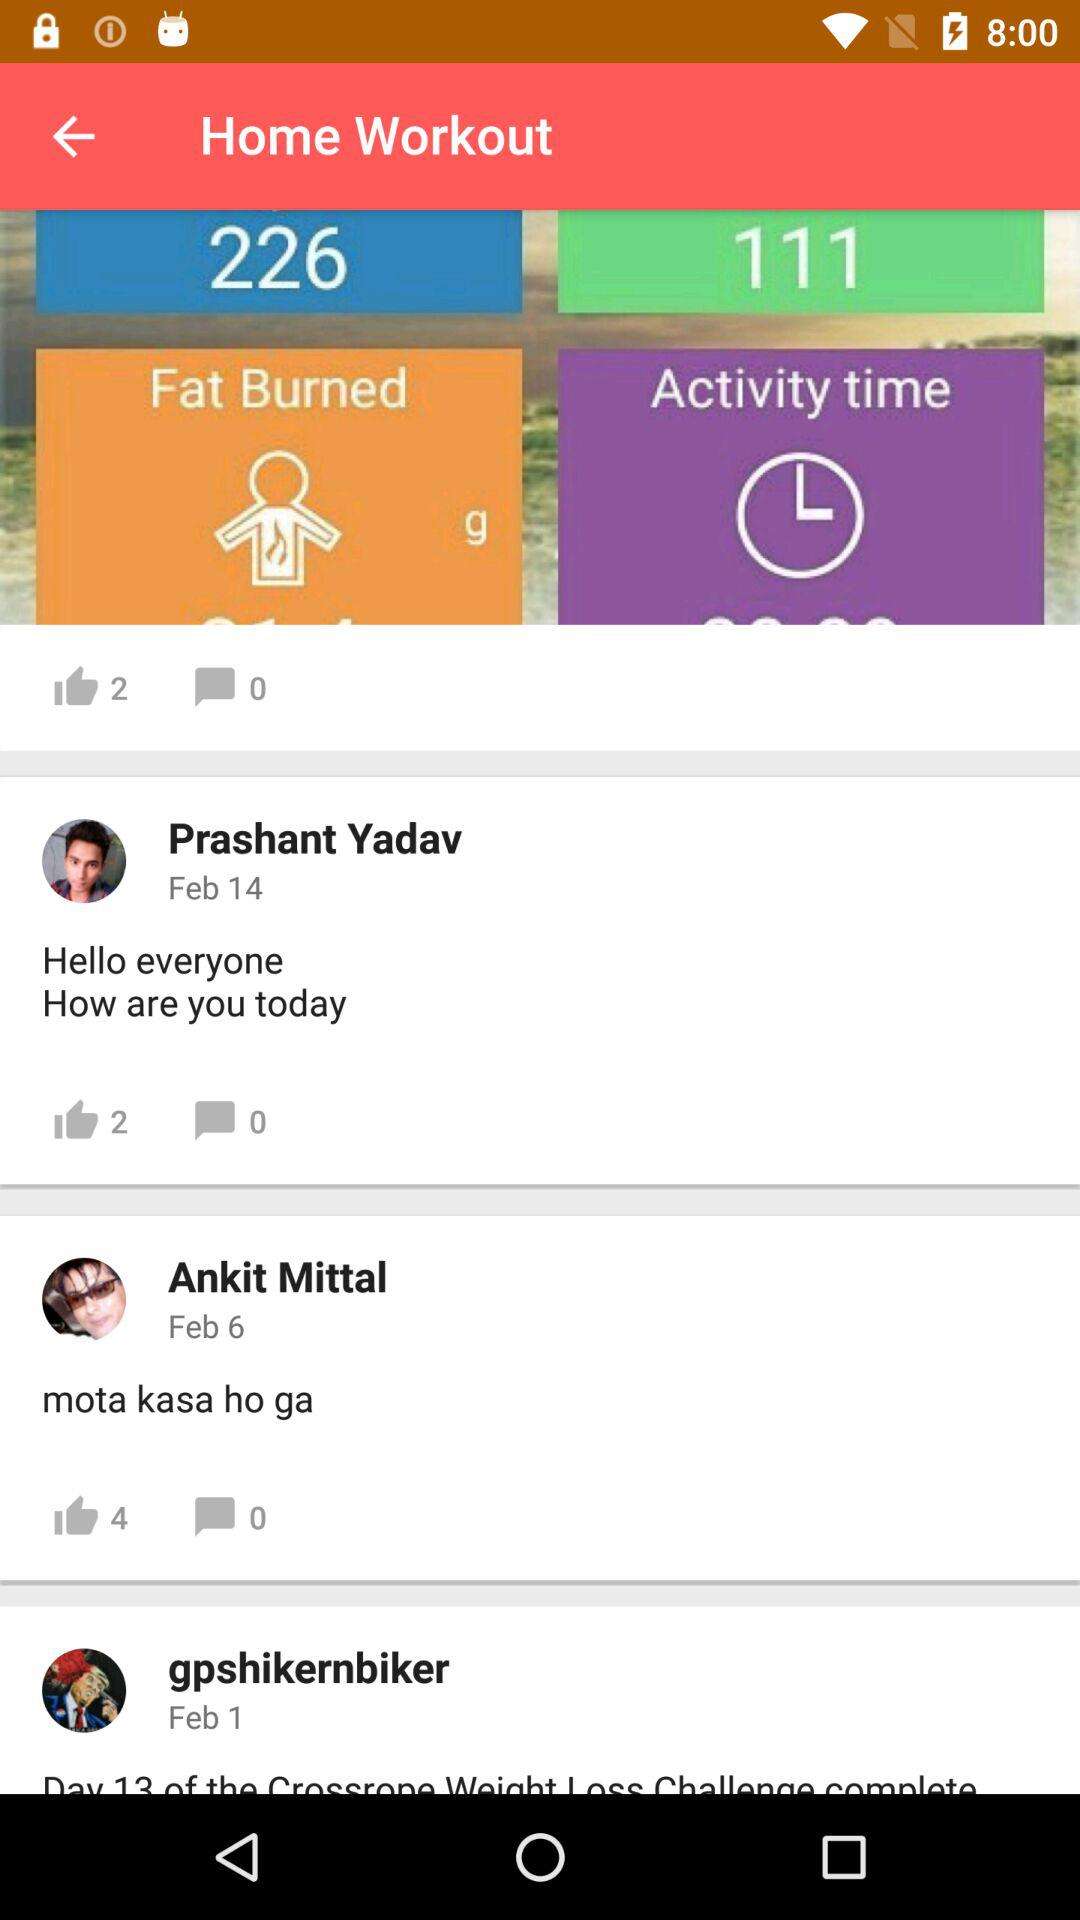Which user has received four likes? The user who has received four likes is Ankit Mittal. 